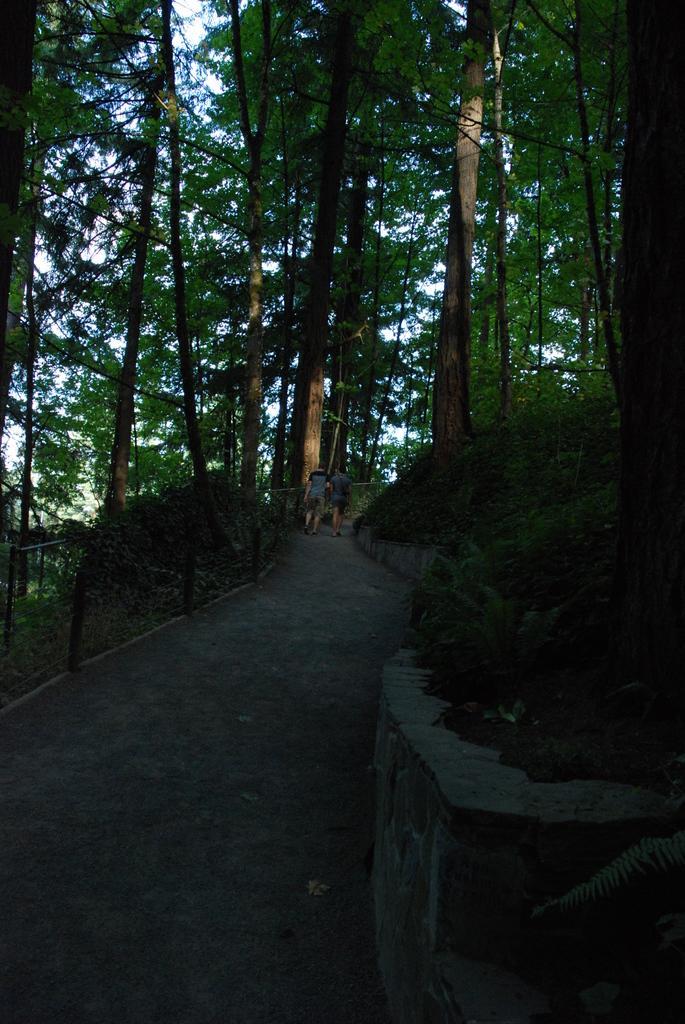Can you describe this image briefly? This picture is clicked outside the city. In the center we can see the two persons seems to be walking on the ground. In the background we can see the trees, sky and plants. 